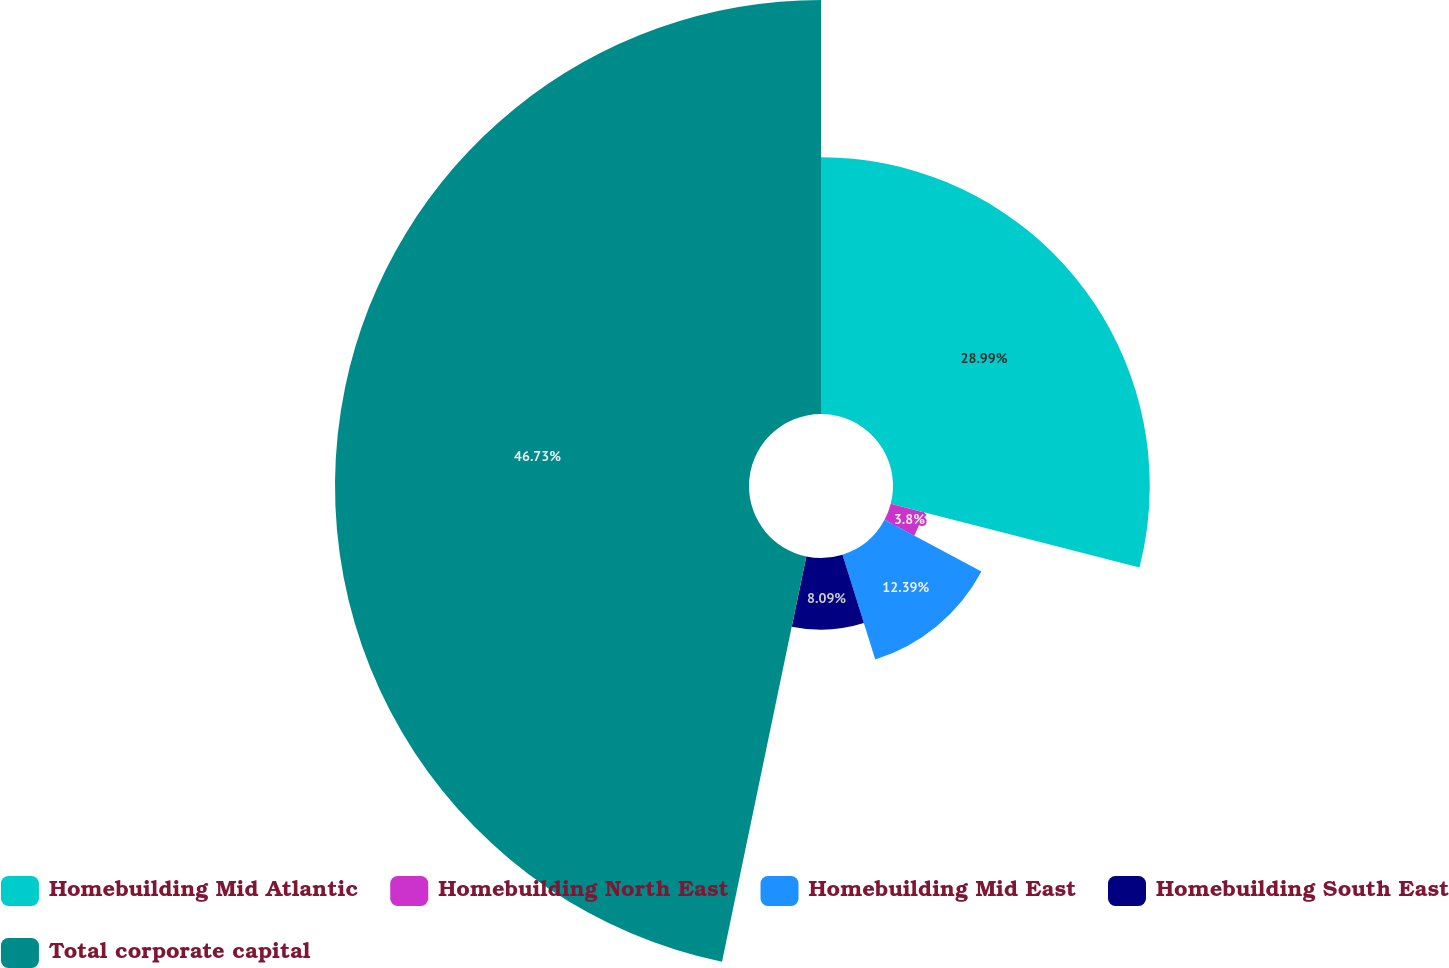Convert chart. <chart><loc_0><loc_0><loc_500><loc_500><pie_chart><fcel>Homebuilding Mid Atlantic<fcel>Homebuilding North East<fcel>Homebuilding Mid East<fcel>Homebuilding South East<fcel>Total corporate capital<nl><fcel>28.99%<fcel>3.8%<fcel>12.39%<fcel>8.09%<fcel>46.74%<nl></chart> 